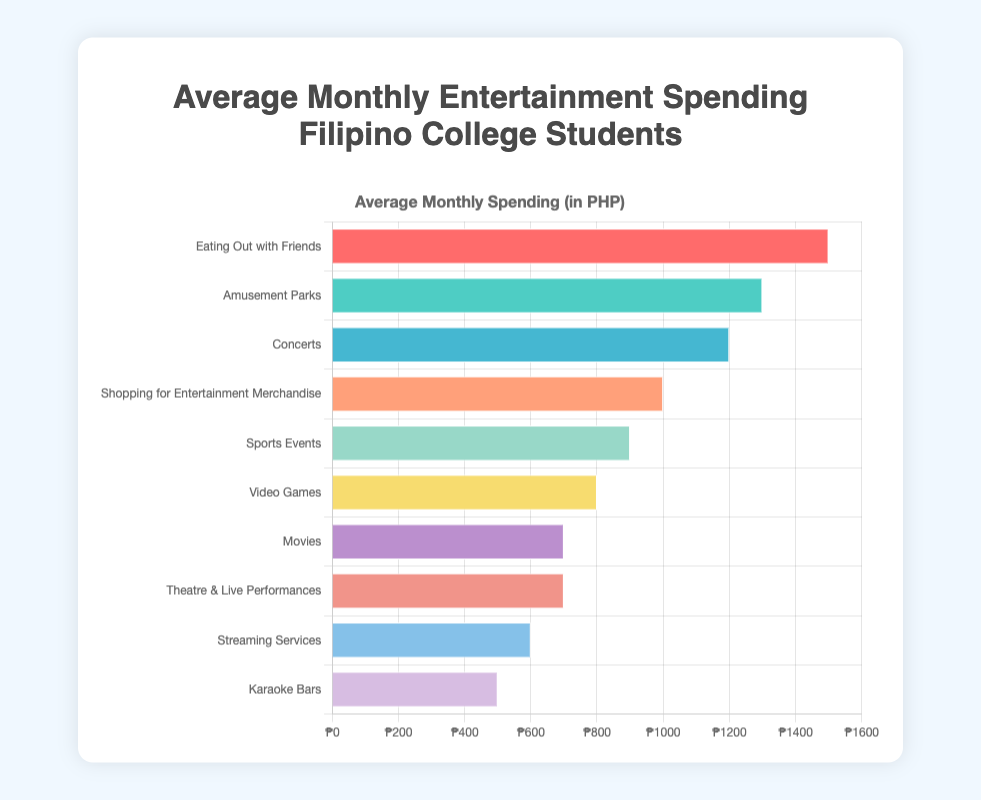Which category has the highest average monthly spending? The bar that extends the furthest on the right-hand side represents the highest spending category. This is "Eating Out with Friends" with an average monthly spending of 1500 PHP.
Answer: Eating Out with Friends Which category has the lowest average monthly spending? The bar that is the shortest on the left-hand side represents the lowest spending category. This is "Karaoke Bars" with an average monthly spending of 500 PHP.
Answer: Karaoke Bars How much more do students spend on Concerts compared to Movies? The spending on Concerts is 1200 PHP, and the spending on Movies is 700 PHP. The difference is calculated by subtracting 700 from 1200: 1200 - 700 = 500 PHP.
Answer: 500 PHP Which category has a higher average monthly spending: Amusement Parks or Shopping for Entertainment Merchandise? By comparing the length of the bars, "Amusement Parks" (1300 PHP) is longer than "Shopping for Entertainment Merchandise" (1000 PHP), indicating a higher spending on Amusement Parks.
Answer: Amusement Parks What is the combined average monthly spending for Movies and Theatre & Live Performances? Both Movies and Theatre & Live Performances have an average spending of 700 PHP each. The combined spending is 700 + 700 = 1400 PHP.
Answer: 1400 PHP What is the total average monthly spending for Video Games, Streaming Services, and Karaoke Bars? The spending on Video Games, Streaming Services, and Karaoke Bars are 800, 600, and 500 PHP respectively. The total is calculated as 800 + 600 + 500 = 1900 PHP.
Answer: 1900 PHP Which categories have the same average monthly spending? The bars for Movies and Theatre & Live Performances both extend to 700 PHP.
Answer: Movies and Theatre & Live Performances What is the difference in spending between the most and least expensive categories? The most expensive category is "Eating Out with Friends" at 1500 PHP, and the least expensive is "Karaoke Bars" at 500 PHP. The difference is 1500 - 500 = 1000 PHP.
Answer: 1000 PHP What is the average monthly spending on categories that have spending above 1000 PHP? The categories with spending above 1000 PHP are "Eating Out with Friends" (1500 PHP), "Amusement Parks" (1300 PHP), and "Concerts" (1200 PHP). The average is calculated as (1500 + 1300 + 1200) / 3 = 4000 / 3 ≈ 1333.33 PHP.
Answer: 1333.33 PHP Which category's spending is closest to the median of the displayed data? If we order the spending from lowest to highest [500, 600, 700, 700, 800, 900, 1000, 1200, 1300, 1500], the median is the average of the 5th (800) and 6th (900) values: (800 + 900) / 2 = 850 PHP. "Sports Events" has the spending closest to this median at 900 PHP.
Answer: Sports Events 